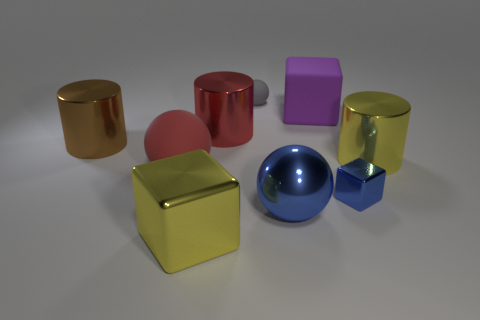The other tiny metallic object that is the same shape as the purple thing is what color?
Keep it short and to the point. Blue. Are there any metal spheres that are right of the big cube right of the large blue thing?
Your answer should be compact. No. What size is the matte cube?
Your response must be concise. Large. There is a large shiny thing that is to the right of the small gray rubber sphere and on the left side of the blue block; what is its shape?
Ensure brevity in your answer.  Sphere. How many red objects are metallic cylinders or large matte spheres?
Offer a terse response. 2. There is a red matte object that is on the left side of the tiny gray ball; is its size the same as the yellow metal thing in front of the red matte object?
Provide a succinct answer. Yes. How many things are either red matte objects or shiny things?
Ensure brevity in your answer.  7. Is there another object of the same shape as the small rubber thing?
Provide a short and direct response. Yes. Are there fewer metal cylinders than small purple spheres?
Offer a very short reply. No. Is the shape of the small rubber object the same as the red rubber thing?
Your answer should be very brief. Yes. 